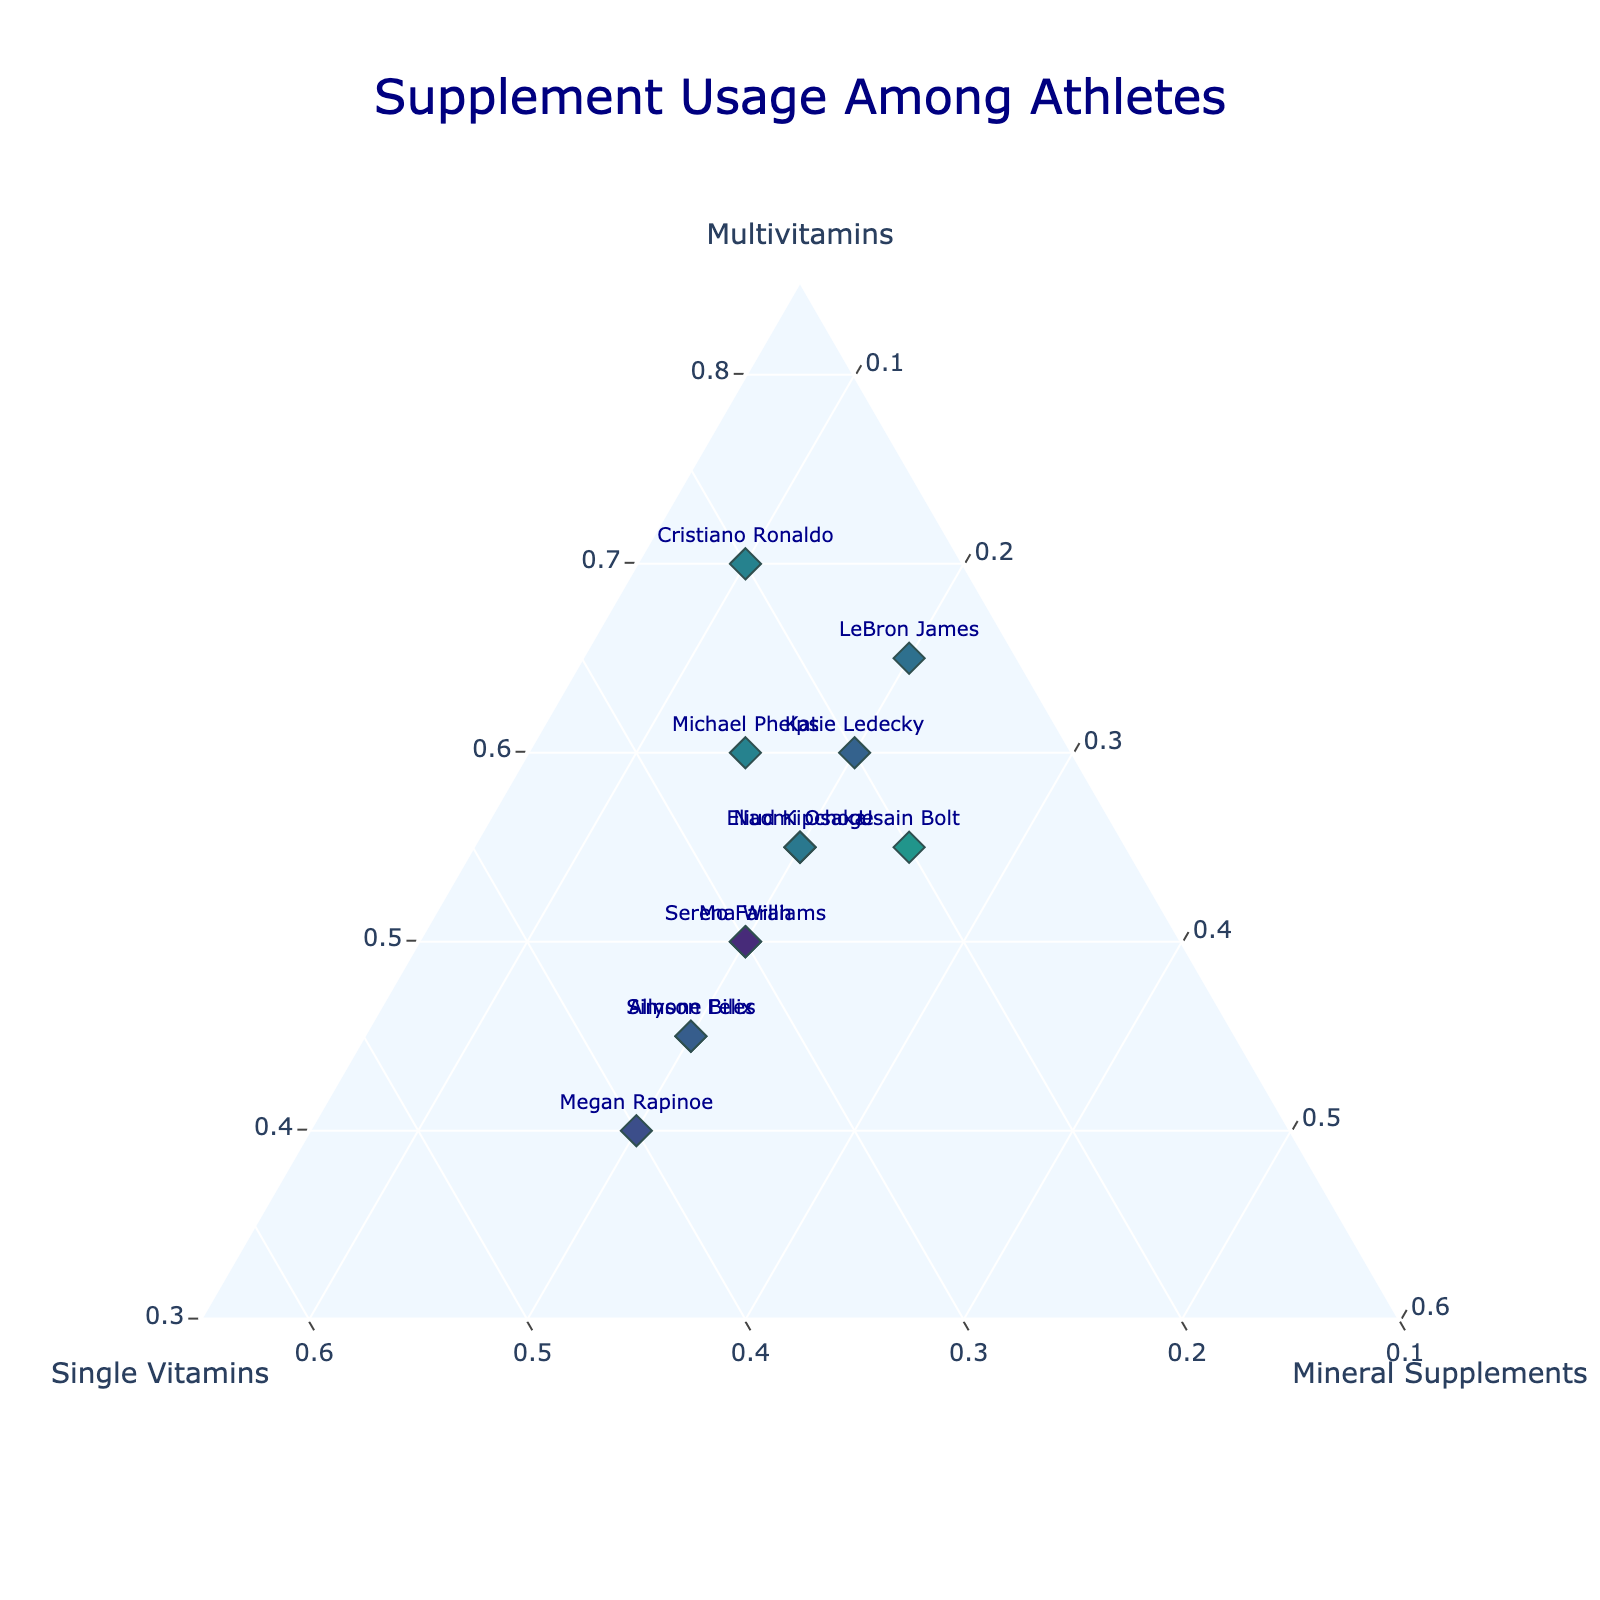What is the title of the plot? The title of the plot is often at the top center and usually gives a clear indication of what the plot is about. From the description, the title is given for clarity.
Answer: Supplement Usage Among Athletes Which athlete has the highest percentage of multivitamin usage? Look at the ternary plot within the multivitamin axis and identify which data point (athlete) reaches the highest point on this axis.
Answer: Cristiano Ronaldo What is the overall trend of mineral supplement usage among the athletes? Observe the placement of the data points on the mineral supplement axis across all athletes. In this plot, mineral supplement percentages appear more towards the middle to lower values.
Answer: Mostly around 20% Who uses the highest percentage of single vitamins? Check the single vitamins axis and find which data point is the furthest along that axis. Each athlete’s label will help identify the outlier.
Answer: Megan Rapinoe Which two athletes have identical distribution percentages of supplement usage? Look for athletes’ data points that overlap exactly or are closest in position on the ternary plot.
Answer: Simone Biles and Allyson Felix How does Serena Williams' supplement usage compare to LeBron James'? Compare the positions of Serena Williams' and LeBron James' data points on the plot. Serena Williams uses 50% multivitamins, 30% single vitamins, and 20% mineral supplements, whereas LeBron James uses 65% multivitamins, 15% single vitamins, and 20% mineral supplements.
Answer: Different: More multivitamins by LeBron What's the average value of multivitamin usage among these athletes? Calculate the sum of the percentages of multivitamins used by all athletes divided by the number of athletes. (60 + 50 + 55 + 45 + 65 + 40 + 70 + 55 + 50 + 45 + 60 + 55) / 12 = 55.
Answer: 55% Which athlete is closest to having an equal distribution of all three types of supplements? Find the data point that is closest to the center of the ternary plot, indicating balanced portions of multivitamins, single vitamins, and mineral supplements.
Answer: Megan Rapinoe Are there any athletes with mineral supplement usage lower than 15%? Check the positions on the mineral supplement axis to see if any data points fall below the 15% point. Cristiano Ronaldo's mineral supplement usage is at 10%.
Answer: Yes, Cristiano Ronaldo Which athlete uses the least multivitamins, and how does their single vitamin and mineral supplement usage compare? Identify the lowest point on the multivitamin axis, then compare the respective single vitamins and mineral supplement usage for that athlete. Megan Rapinoe uses the least multivitamins (40%) and balances her usage equally between single vitamins (40%) and mineral supplements (20%).
Answer: Megan Rapinoe: 40% single vitamins and 20% mineral supplements 